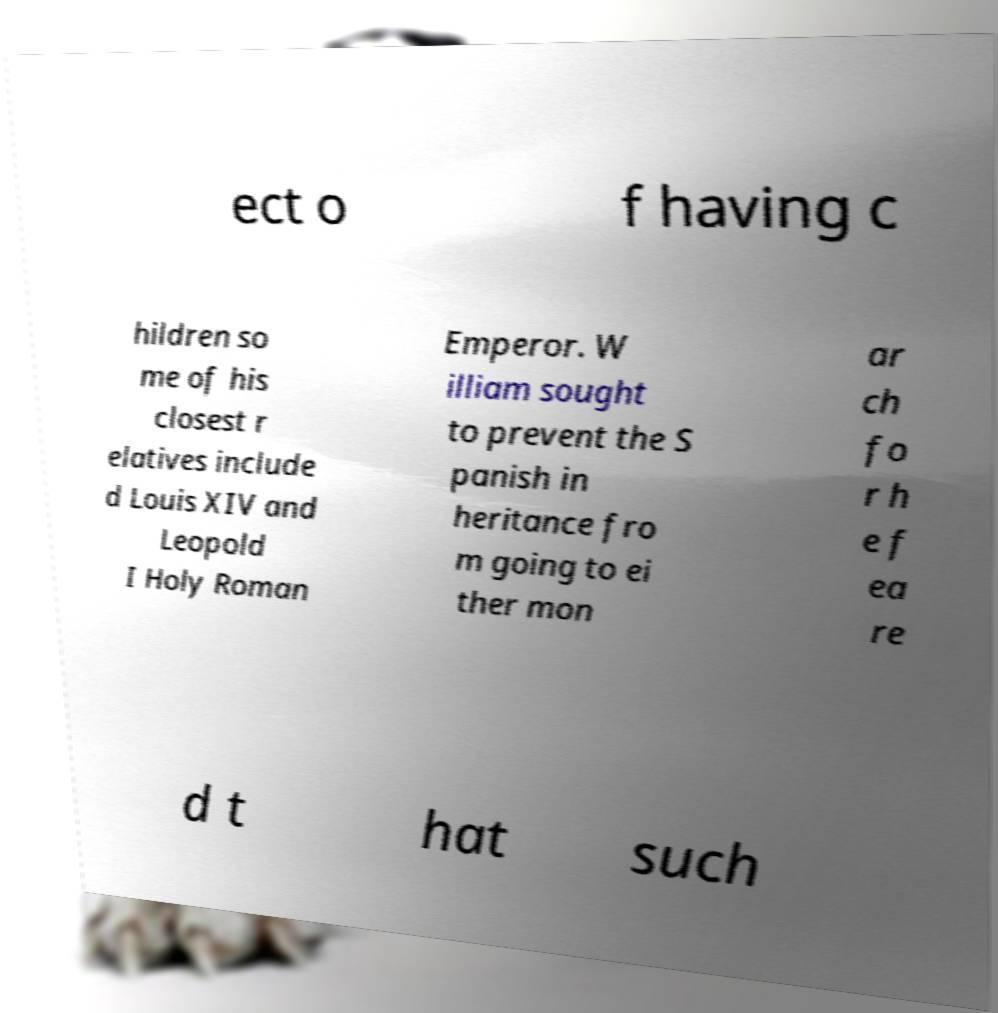Can you accurately transcribe the text from the provided image for me? ect o f having c hildren so me of his closest r elatives include d Louis XIV and Leopold I Holy Roman Emperor. W illiam sought to prevent the S panish in heritance fro m going to ei ther mon ar ch fo r h e f ea re d t hat such 